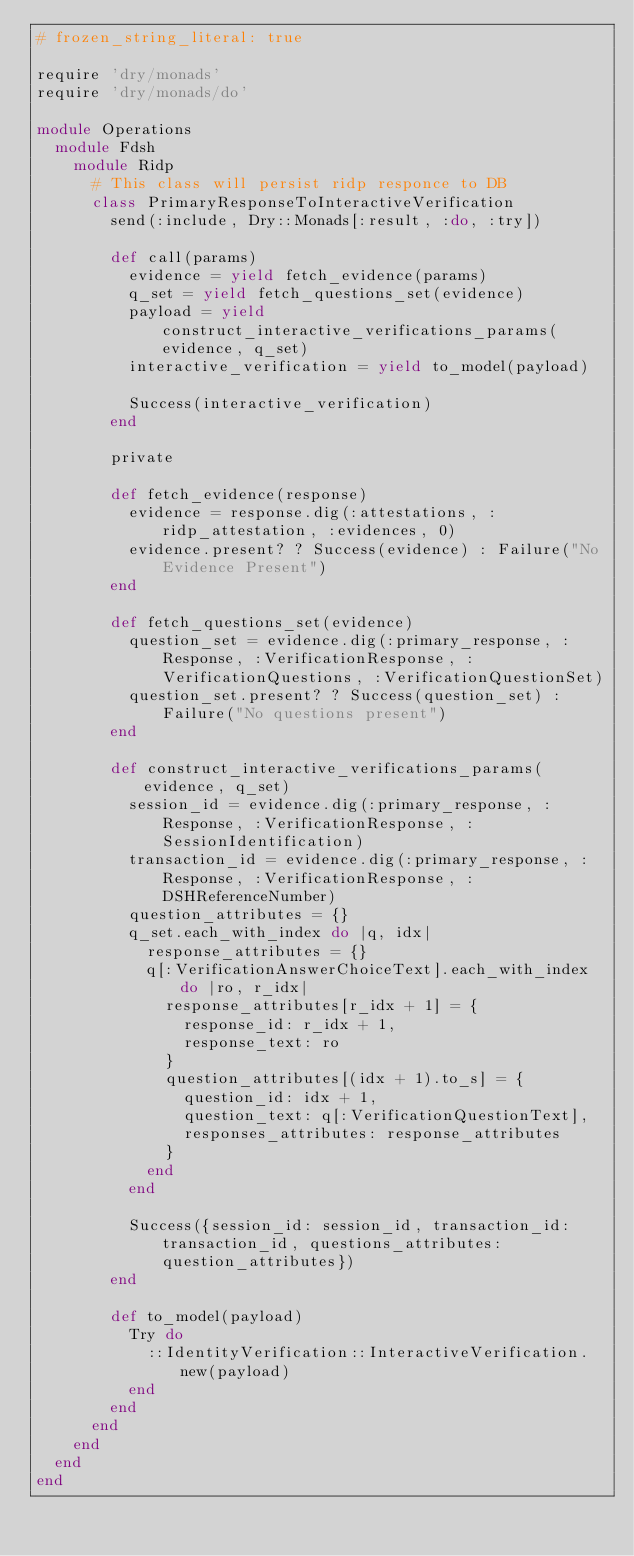<code> <loc_0><loc_0><loc_500><loc_500><_Ruby_># frozen_string_literal: true

require 'dry/monads'
require 'dry/monads/do'

module Operations
  module Fdsh
    module Ridp
      # This class will persist ridp responce to DB
      class PrimaryResponseToInteractiveVerification
        send(:include, Dry::Monads[:result, :do, :try])

        def call(params)
          evidence = yield fetch_evidence(params)
          q_set = yield fetch_questions_set(evidence)
          payload = yield construct_interactive_verifications_params(evidence, q_set)
          interactive_verification = yield to_model(payload)

          Success(interactive_verification)
        end

        private

        def fetch_evidence(response)
          evidence = response.dig(:attestations, :ridp_attestation, :evidences, 0)
          evidence.present? ? Success(evidence) : Failure("No Evidence Present")
        end

        def fetch_questions_set(evidence)
          question_set = evidence.dig(:primary_response, :Response, :VerificationResponse, :VerificationQuestions, :VerificationQuestionSet)
          question_set.present? ? Success(question_set) : Failure("No questions present")
        end

        def construct_interactive_verifications_params(evidence, q_set)
          session_id = evidence.dig(:primary_response, :Response, :VerificationResponse, :SessionIdentification)
          transaction_id = evidence.dig(:primary_response, :Response, :VerificationResponse, :DSHReferenceNumber)
          question_attributes = {}
          q_set.each_with_index do |q, idx|
            response_attributes = {}
            q[:VerificationAnswerChoiceText].each_with_index do |ro, r_idx|
              response_attributes[r_idx + 1] = {
                response_id: r_idx + 1,
                response_text: ro
              }
              question_attributes[(idx + 1).to_s] = {
                question_id: idx + 1,
                question_text: q[:VerificationQuestionText],
                responses_attributes: response_attributes
              }
            end
          end

          Success({session_id: session_id, transaction_id: transaction_id, questions_attributes: question_attributes})
        end

        def to_model(payload)
          Try do
            ::IdentityVerification::InteractiveVerification.new(payload)
          end
        end
      end
    end
  end
end
</code> 